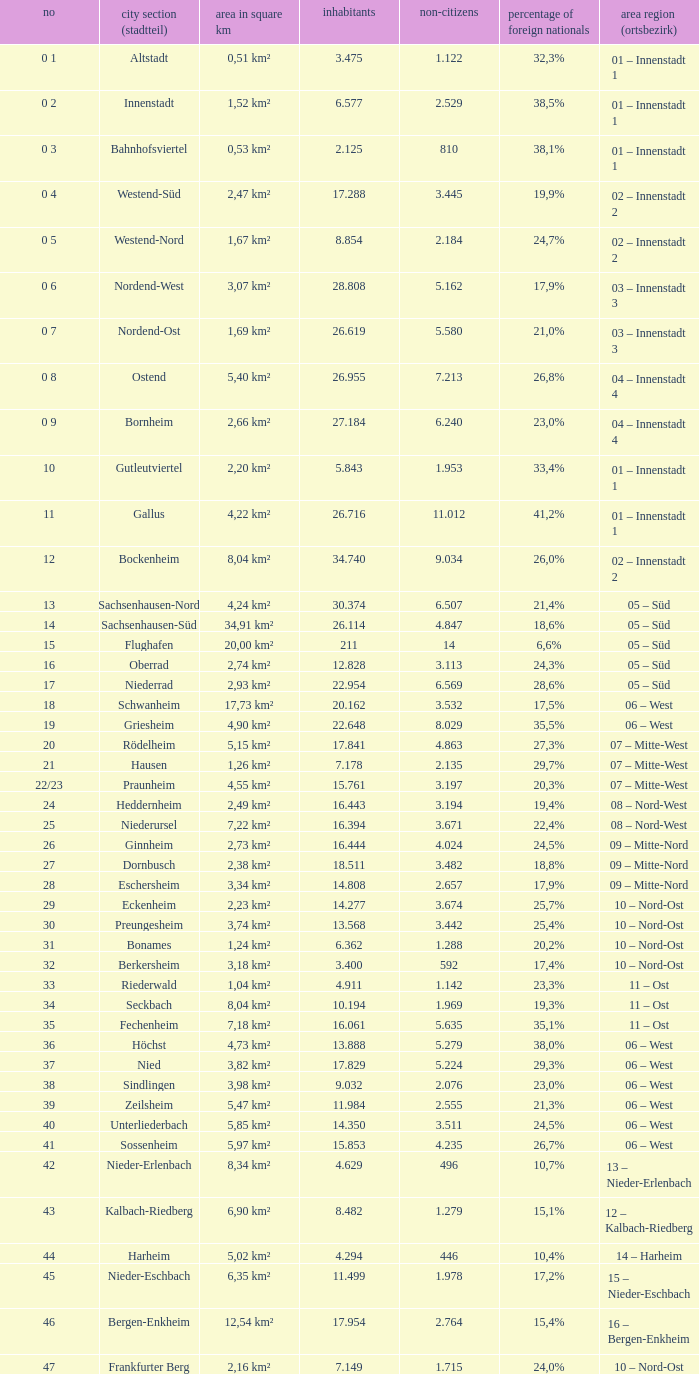How many foreigners in percentage terms had a population of 4.911? 1.0. 